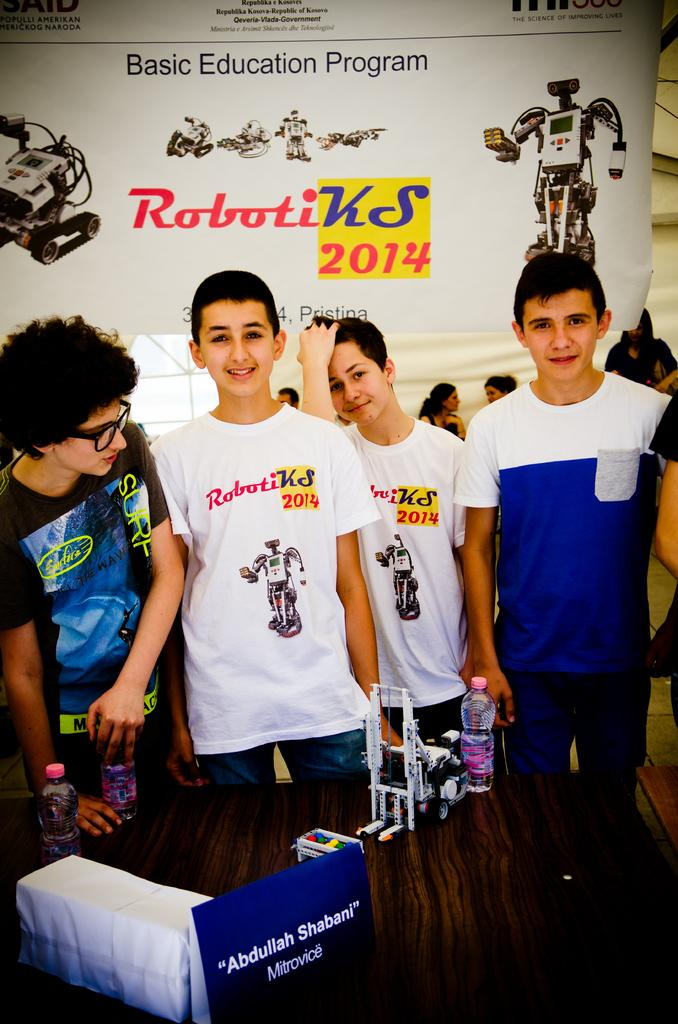<image>
Present a compact description of the photo's key features. Four kids standing in front of a Robotiks 2014 sign. 